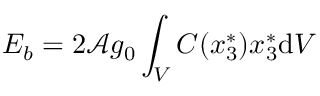<formula> <loc_0><loc_0><loc_500><loc_500>E _ { b } = 2 \mathcal { A } g _ { 0 } \int _ { V } C ( x _ { 3 } ^ { * } ) x _ { 3 } ^ { * } d V</formula> 